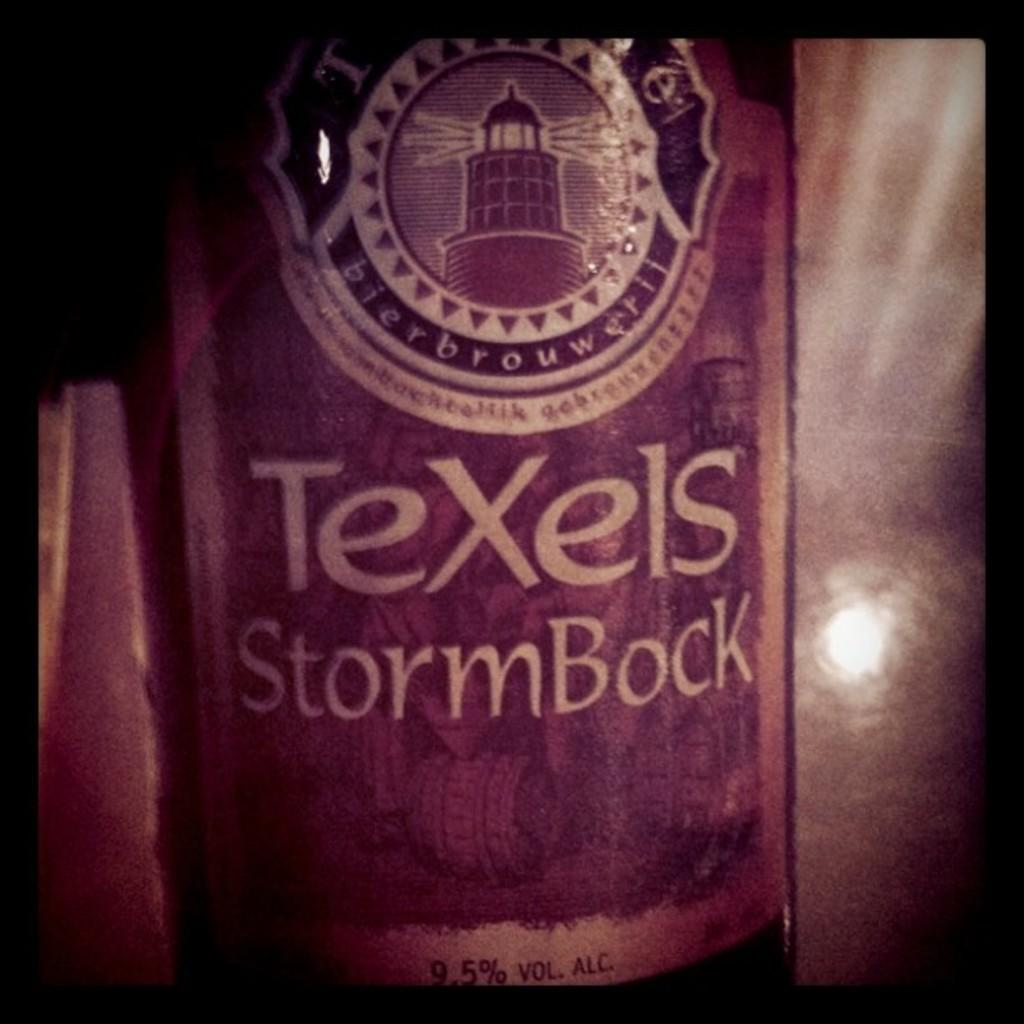What object can be seen in the image? There is a bottle in the image. What type of hat is on top of the bottle in the image? There is no hat present on top of the bottle in the image. What type of seed can be seen growing from the bottle in the image? There is no seed or plant growing from the bottle in the image. 